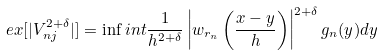Convert formula to latex. <formula><loc_0><loc_0><loc_500><loc_500>\ e x [ | V _ { n j } ^ { 2 + \delta } | ] = \inf i n t \frac { 1 } { h ^ { 2 + \delta } } \left | w _ { r _ { n } } \left ( \frac { x - y } { h } \right ) \right | ^ { 2 + \delta } g _ { n } ( y ) d y</formula> 